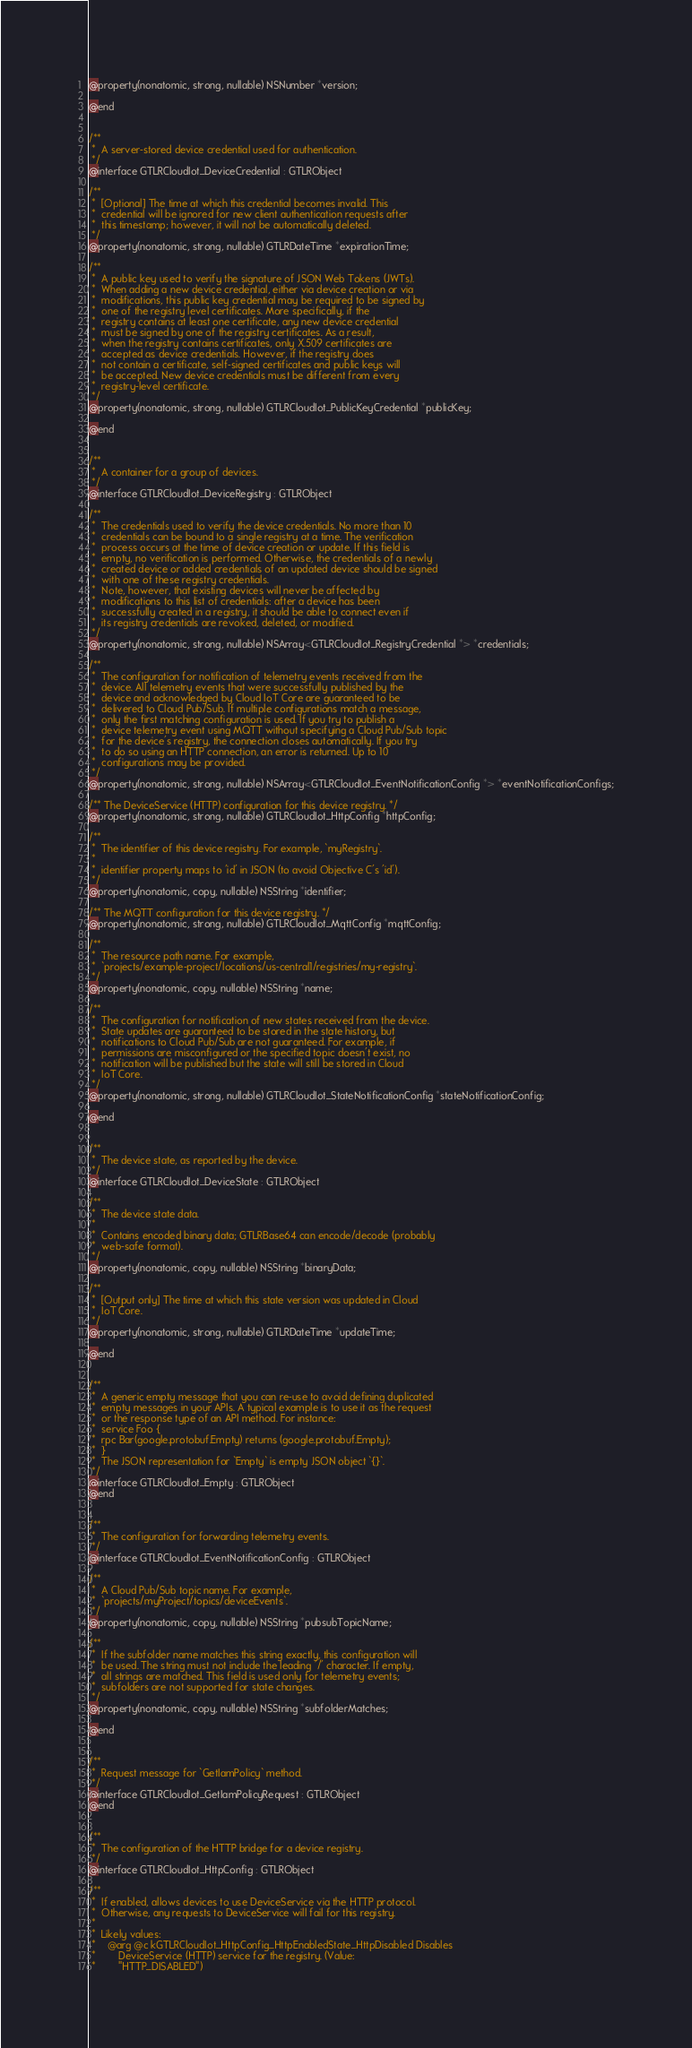Convert code to text. <code><loc_0><loc_0><loc_500><loc_500><_C_>@property(nonatomic, strong, nullable) NSNumber *version;

@end


/**
 *  A server-stored device credential used for authentication.
 */
@interface GTLRCloudIot_DeviceCredential : GTLRObject

/**
 *  [Optional] The time at which this credential becomes invalid. This
 *  credential will be ignored for new client authentication requests after
 *  this timestamp; however, it will not be automatically deleted.
 */
@property(nonatomic, strong, nullable) GTLRDateTime *expirationTime;

/**
 *  A public key used to verify the signature of JSON Web Tokens (JWTs).
 *  When adding a new device credential, either via device creation or via
 *  modifications, this public key credential may be required to be signed by
 *  one of the registry level certificates. More specifically, if the
 *  registry contains at least one certificate, any new device credential
 *  must be signed by one of the registry certificates. As a result,
 *  when the registry contains certificates, only X.509 certificates are
 *  accepted as device credentials. However, if the registry does
 *  not contain a certificate, self-signed certificates and public keys will
 *  be accepted. New device credentials must be different from every
 *  registry-level certificate.
 */
@property(nonatomic, strong, nullable) GTLRCloudIot_PublicKeyCredential *publicKey;

@end


/**
 *  A container for a group of devices.
 */
@interface GTLRCloudIot_DeviceRegistry : GTLRObject

/**
 *  The credentials used to verify the device credentials. No more than 10
 *  credentials can be bound to a single registry at a time. The verification
 *  process occurs at the time of device creation or update. If this field is
 *  empty, no verification is performed. Otherwise, the credentials of a newly
 *  created device or added credentials of an updated device should be signed
 *  with one of these registry credentials.
 *  Note, however, that existing devices will never be affected by
 *  modifications to this list of credentials: after a device has been
 *  successfully created in a registry, it should be able to connect even if
 *  its registry credentials are revoked, deleted, or modified.
 */
@property(nonatomic, strong, nullable) NSArray<GTLRCloudIot_RegistryCredential *> *credentials;

/**
 *  The configuration for notification of telemetry events received from the
 *  device. All telemetry events that were successfully published by the
 *  device and acknowledged by Cloud IoT Core are guaranteed to be
 *  delivered to Cloud Pub/Sub. If multiple configurations match a message,
 *  only the first matching configuration is used. If you try to publish a
 *  device telemetry event using MQTT without specifying a Cloud Pub/Sub topic
 *  for the device's registry, the connection closes automatically. If you try
 *  to do so using an HTTP connection, an error is returned. Up to 10
 *  configurations may be provided.
 */
@property(nonatomic, strong, nullable) NSArray<GTLRCloudIot_EventNotificationConfig *> *eventNotificationConfigs;

/** The DeviceService (HTTP) configuration for this device registry. */
@property(nonatomic, strong, nullable) GTLRCloudIot_HttpConfig *httpConfig;

/**
 *  The identifier of this device registry. For example, `myRegistry`.
 *
 *  identifier property maps to 'id' in JSON (to avoid Objective C's 'id').
 */
@property(nonatomic, copy, nullable) NSString *identifier;

/** The MQTT configuration for this device registry. */
@property(nonatomic, strong, nullable) GTLRCloudIot_MqttConfig *mqttConfig;

/**
 *  The resource path name. For example,
 *  `projects/example-project/locations/us-central1/registries/my-registry`.
 */
@property(nonatomic, copy, nullable) NSString *name;

/**
 *  The configuration for notification of new states received from the device.
 *  State updates are guaranteed to be stored in the state history, but
 *  notifications to Cloud Pub/Sub are not guaranteed. For example, if
 *  permissions are misconfigured or the specified topic doesn't exist, no
 *  notification will be published but the state will still be stored in Cloud
 *  IoT Core.
 */
@property(nonatomic, strong, nullable) GTLRCloudIot_StateNotificationConfig *stateNotificationConfig;

@end


/**
 *  The device state, as reported by the device.
 */
@interface GTLRCloudIot_DeviceState : GTLRObject

/**
 *  The device state data.
 *
 *  Contains encoded binary data; GTLRBase64 can encode/decode (probably
 *  web-safe format).
 */
@property(nonatomic, copy, nullable) NSString *binaryData;

/**
 *  [Output only] The time at which this state version was updated in Cloud
 *  IoT Core.
 */
@property(nonatomic, strong, nullable) GTLRDateTime *updateTime;

@end


/**
 *  A generic empty message that you can re-use to avoid defining duplicated
 *  empty messages in your APIs. A typical example is to use it as the request
 *  or the response type of an API method. For instance:
 *  service Foo {
 *  rpc Bar(google.protobuf.Empty) returns (google.protobuf.Empty);
 *  }
 *  The JSON representation for `Empty` is empty JSON object `{}`.
 */
@interface GTLRCloudIot_Empty : GTLRObject
@end


/**
 *  The configuration for forwarding telemetry events.
 */
@interface GTLRCloudIot_EventNotificationConfig : GTLRObject

/**
 *  A Cloud Pub/Sub topic name. For example,
 *  `projects/myProject/topics/deviceEvents`.
 */
@property(nonatomic, copy, nullable) NSString *pubsubTopicName;

/**
 *  If the subfolder name matches this string exactly, this configuration will
 *  be used. The string must not include the leading '/' character. If empty,
 *  all strings are matched. This field is used only for telemetry events;
 *  subfolders are not supported for state changes.
 */
@property(nonatomic, copy, nullable) NSString *subfolderMatches;

@end


/**
 *  Request message for `GetIamPolicy` method.
 */
@interface GTLRCloudIot_GetIamPolicyRequest : GTLRObject
@end


/**
 *  The configuration of the HTTP bridge for a device registry.
 */
@interface GTLRCloudIot_HttpConfig : GTLRObject

/**
 *  If enabled, allows devices to use DeviceService via the HTTP protocol.
 *  Otherwise, any requests to DeviceService will fail for this registry.
 *
 *  Likely values:
 *    @arg @c kGTLRCloudIot_HttpConfig_HttpEnabledState_HttpDisabled Disables
 *        DeviceService (HTTP) service for the registry. (Value:
 *        "HTTP_DISABLED")</code> 